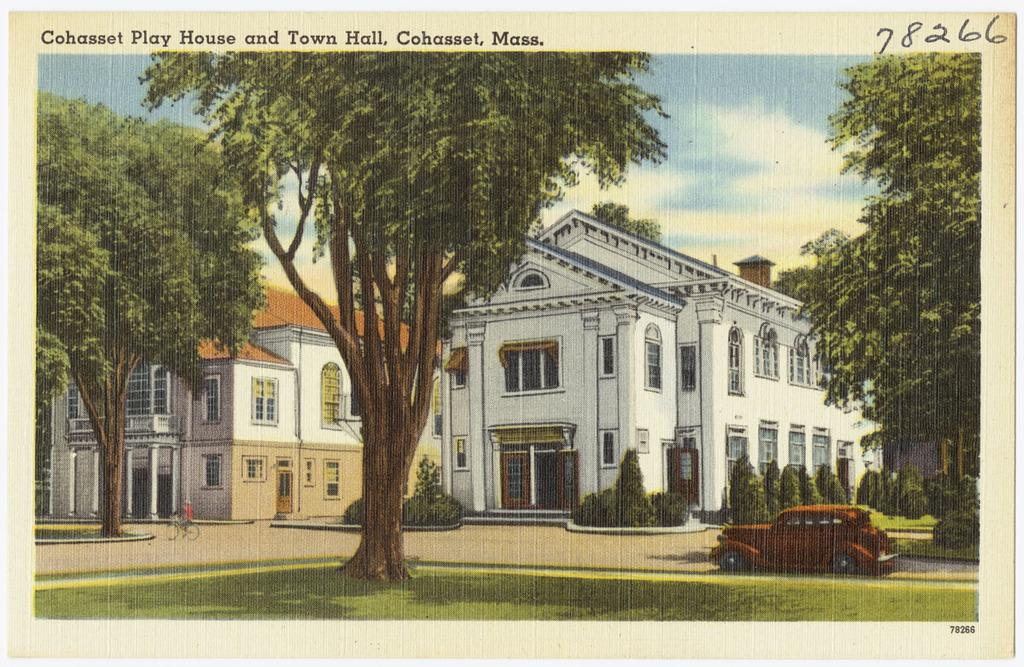What type of vegetation can be seen in the image? There is grass in the image. What mode of transportation is present in the image? There is a car on the ground and a person on a bicycle in the image. What other natural elements can be seen in the image? There are trees in the image. Is there any text visible in the image? Yes, there is some text visible in the image. What type of structures are present in the image? There are buildings with windows in the image. What can be seen in the background of the image? The sky is visible in the background of the image. How many astronauts are visible in the image? There are no astronauts or any space-related elements present in the image. What type of care is being provided to the person on the bicycle in the image? There is no indication of any care being provided in the image; it simply shows a person on a bicycle. 